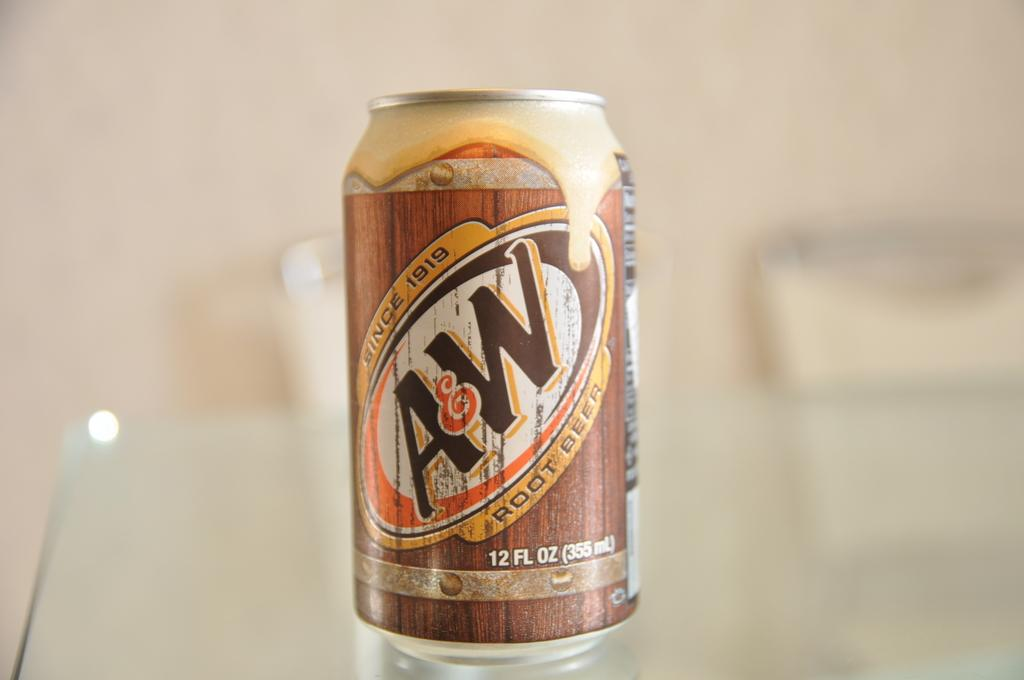Provide a one-sentence caption for the provided image. A&W root beer is a very tasty drink. 